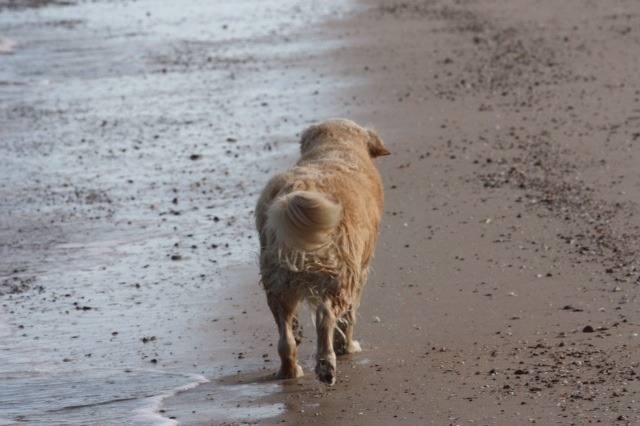Describe the objects in this image and their specific colors. I can see a dog in gray, tan, and black tones in this image. 